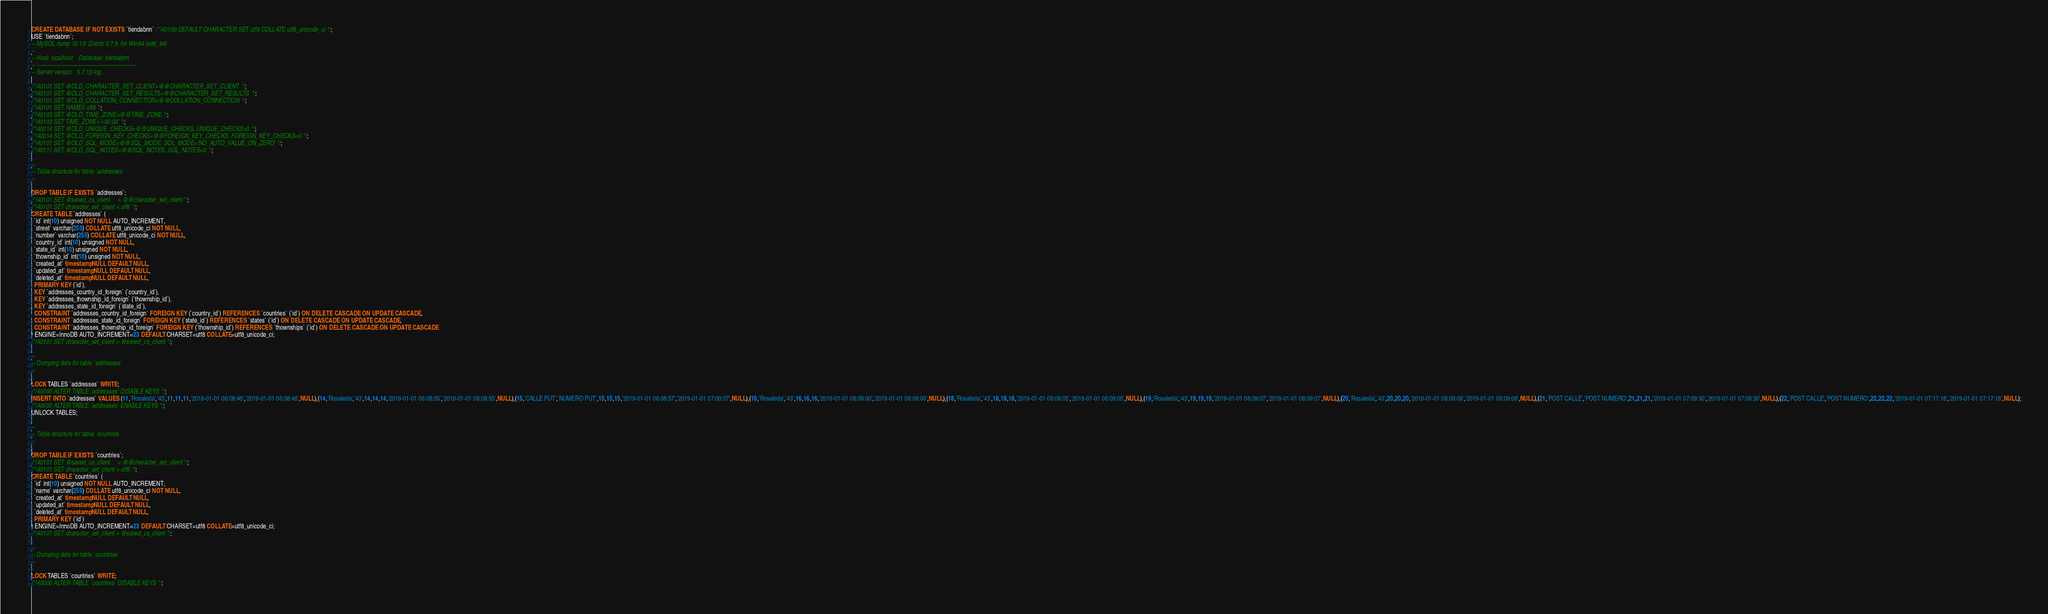<code> <loc_0><loc_0><loc_500><loc_500><_SQL_>CREATE DATABASE  IF NOT EXISTS `tiendabnn` /*!40100 DEFAULT CHARACTER SET utf8 COLLATE utf8_unicode_ci */;
USE `tiendabnn`;
-- MySQL dump 10.13  Distrib 5.7.9, for Win64 (x86_64)
--
-- Host: localhost    Database: tiendabnn
-- ------------------------------------------------------
-- Server version	5.7.12-log

/*!40101 SET @OLD_CHARACTER_SET_CLIENT=@@CHARACTER_SET_CLIENT */;
/*!40101 SET @OLD_CHARACTER_SET_RESULTS=@@CHARACTER_SET_RESULTS */;
/*!40101 SET @OLD_COLLATION_CONNECTION=@@COLLATION_CONNECTION */;
/*!40101 SET NAMES utf8 */;
/*!40103 SET @OLD_TIME_ZONE=@@TIME_ZONE */;
/*!40103 SET TIME_ZONE='+00:00' */;
/*!40014 SET @OLD_UNIQUE_CHECKS=@@UNIQUE_CHECKS, UNIQUE_CHECKS=0 */;
/*!40014 SET @OLD_FOREIGN_KEY_CHECKS=@@FOREIGN_KEY_CHECKS, FOREIGN_KEY_CHECKS=0 */;
/*!40101 SET @OLD_SQL_MODE=@@SQL_MODE, SQL_MODE='NO_AUTO_VALUE_ON_ZERO' */;
/*!40111 SET @OLD_SQL_NOTES=@@SQL_NOTES, SQL_NOTES=0 */;

--
-- Table structure for table `addresses`
--

DROP TABLE IF EXISTS `addresses`;
/*!40101 SET @saved_cs_client     = @@character_set_client */;
/*!40101 SET character_set_client = utf8 */;
CREATE TABLE `addresses` (
  `id` int(10) unsigned NOT NULL AUTO_INCREMENT,
  `street` varchar(255) COLLATE utf8_unicode_ci NOT NULL,
  `number` varchar(255) COLLATE utf8_unicode_ci NOT NULL,
  `country_id` int(10) unsigned NOT NULL,
  `state_id` int(10) unsigned NOT NULL,
  `thownship_id` int(10) unsigned NOT NULL,
  `created_at` timestamp NULL DEFAULT NULL,
  `updated_at` timestamp NULL DEFAULT NULL,
  `deleted_at` timestamp NULL DEFAULT NULL,
  PRIMARY KEY (`id`),
  KEY `addresses_country_id_foreign` (`country_id`),
  KEY `addresses_thownship_id_foreign` (`thownship_id`),
  KEY `addresses_state_id_foreign` (`state_id`),
  CONSTRAINT `addresses_country_id_foreign` FOREIGN KEY (`country_id`) REFERENCES `countries` (`id`) ON DELETE CASCADE ON UPDATE CASCADE,
  CONSTRAINT `addresses_state_id_foreign` FOREIGN KEY (`state_id`) REFERENCES `states` (`id`) ON DELETE CASCADE ON UPDATE CASCADE,
  CONSTRAINT `addresses_thownship_id_foreign` FOREIGN KEY (`thownship_id`) REFERENCES `thownships` (`id`) ON DELETE CASCADE ON UPDATE CASCADE
) ENGINE=InnoDB AUTO_INCREMENT=23 DEFAULT CHARSET=utf8 COLLATE=utf8_unicode_ci;
/*!40101 SET character_set_client = @saved_cs_client */;

--
-- Dumping data for table `addresses`
--

LOCK TABLES `addresses` WRITE;
/*!40000 ALTER TABLE `addresses` DISABLE KEYS */;
INSERT INTO `addresses` VALUES (11,'Rosaleda','43',11,11,11,'2019-01-01 06:08:46','2019-01-01 06:08:46',NULL),(14,'Rosaleda','43',14,14,14,'2019-01-01 06:08:55','2019-01-01 06:08:55',NULL),(15,'CALLE PUT','NUMERO PUT',15,15,15,'2019-01-01 06:08:57','2019-01-01 07:00:57',NULL),(16,'Rosaleda','43',16,16,16,'2019-01-01 06:09:00','2019-01-01 06:09:00',NULL),(18,'Rosaleda','43',18,18,18,'2019-01-01 06:09:05','2019-01-01 06:09:05',NULL),(19,'Rosaleda','43',19,19,19,'2019-01-01 06:09:07','2019-01-01 06:09:07',NULL),(20,'Rosaleda','43',20,20,20,'2019-01-01 06:09:09','2019-01-01 06:09:09',NULL),(21,'POST CALLE','POST NUMERO',21,21,21,'2019-01-01 07:09:30','2019-01-01 07:09:30',NULL),(22,'POST CALLE','POST NUMERO',22,22,22,'2019-01-01 07:17:18','2019-01-01 07:17:18',NULL);
/*!40000 ALTER TABLE `addresses` ENABLE KEYS */;
UNLOCK TABLES;

--
-- Table structure for table `countries`
--

DROP TABLE IF EXISTS `countries`;
/*!40101 SET @saved_cs_client     = @@character_set_client */;
/*!40101 SET character_set_client = utf8 */;
CREATE TABLE `countries` (
  `id` int(10) unsigned NOT NULL AUTO_INCREMENT,
  `name` varchar(255) COLLATE utf8_unicode_ci NOT NULL,
  `created_at` timestamp NULL DEFAULT NULL,
  `updated_at` timestamp NULL DEFAULT NULL,
  `deleted_at` timestamp NULL DEFAULT NULL,
  PRIMARY KEY (`id`)
) ENGINE=InnoDB AUTO_INCREMENT=23 DEFAULT CHARSET=utf8 COLLATE=utf8_unicode_ci;
/*!40101 SET character_set_client = @saved_cs_client */;

--
-- Dumping data for table `countries`
--

LOCK TABLES `countries` WRITE;
/*!40000 ALTER TABLE `countries` DISABLE KEYS */;</code> 